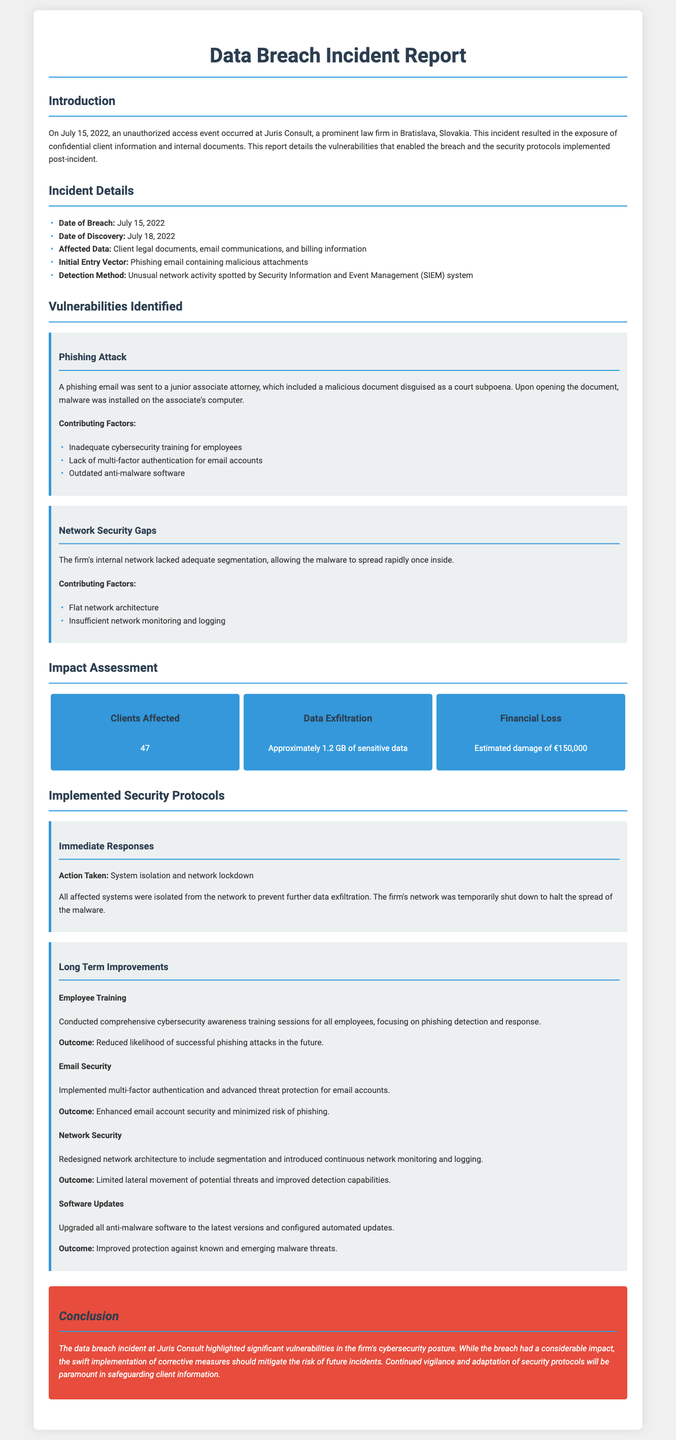What was the date of the breach? The date of the breach is specified in the Incident Details section of the document.
Answer: July 15, 2022 How many clients were affected? The number of clients affected is listed in the Impact Assessment section.
Answer: 47 What was the estimated financial loss? The estimated financial loss is provided in the Impact Assessment section, indicating the financial damage caused by the breach.
Answer: €150,000 What was the initial entry vector of the breach? The initial entry vector is detailed under the Incident Details section, identifying how the breach occurred.
Answer: Phishing email containing malicious attachments What was one of the contributing factors to the phishing attack? The contributing factors are mentioned in the Vulnerabilities Identified section, highlighting issues related to cybersecurity training.
Answer: Inadequate cybersecurity training for employees Which security measure was implemented for email accounts? The implemented security measures for email accounts are listed in the Long Term Improvements section.
Answer: Multi-factor authentication What was the consequence of the flat network architecture? The consequence is discussed in the Vulnerabilities Identified section concerning network security.
Answer: Allowed the malware to spread rapidly What action was taken immediately after the breach? The immediate response actions are detailed in the Implemented Security Protocols section.
Answer: System isolation and network lockdown 